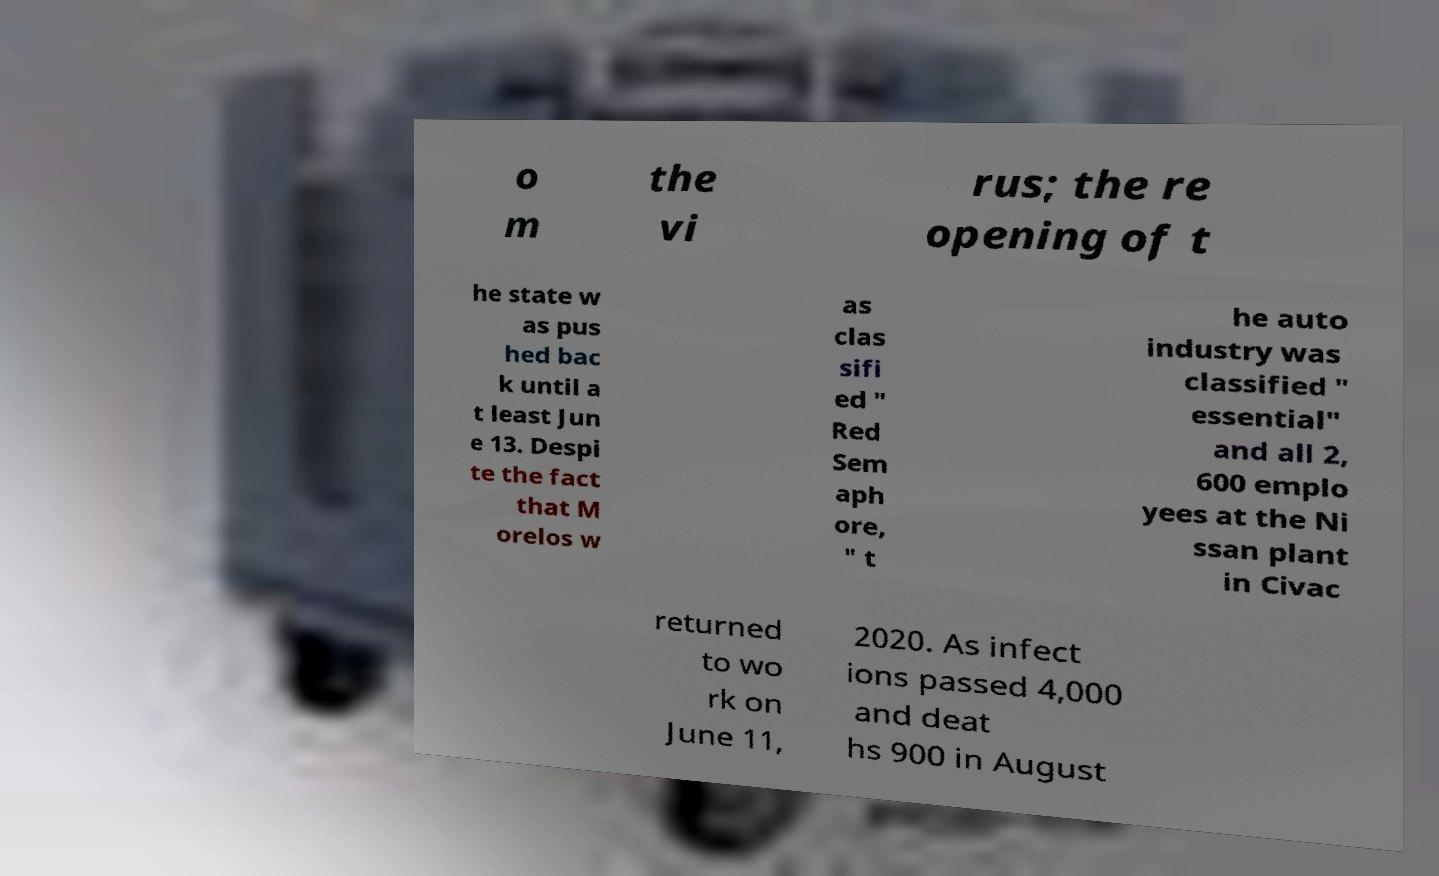Please identify and transcribe the text found in this image. o m the vi rus; the re opening of t he state w as pus hed bac k until a t least Jun e 13. Despi te the fact that M orelos w as clas sifi ed ″ Red Sem aph ore, ″ t he auto industry was classified ″ essential″ and all 2, 600 emplo yees at the Ni ssan plant in Civac returned to wo rk on June 11, 2020. As infect ions passed 4,000 and deat hs 900 in August 